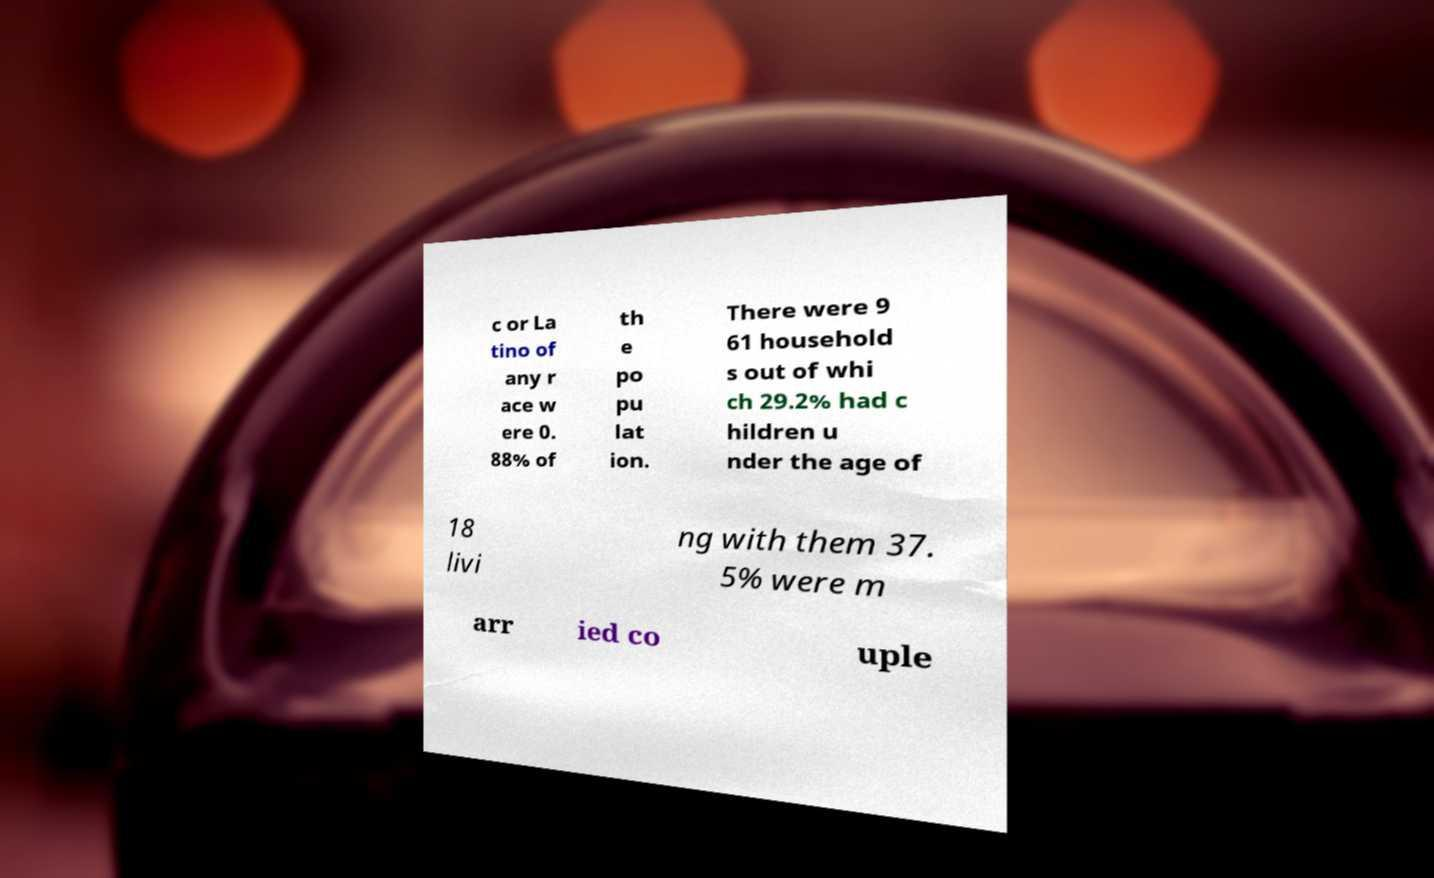For documentation purposes, I need the text within this image transcribed. Could you provide that? c or La tino of any r ace w ere 0. 88% of th e po pu lat ion. There were 9 61 household s out of whi ch 29.2% had c hildren u nder the age of 18 livi ng with them 37. 5% were m arr ied co uple 